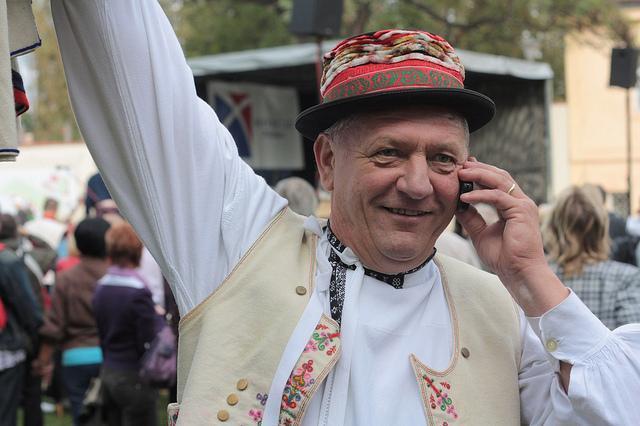How many people are there?
Give a very brief answer. 6. How many mouse pads ar? there?
Give a very brief answer. 0. 